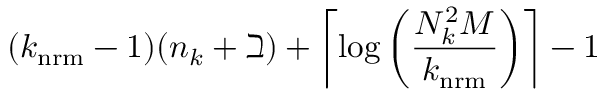<formula> <loc_0><loc_0><loc_500><loc_500>( k _ { n r m } - 1 ) ( n _ { k } + \beth ) + \left \lceil \log \left ( \frac { N _ { k } ^ { 2 } M } { k _ { n r m } } \right ) \right \rceil - 1</formula> 